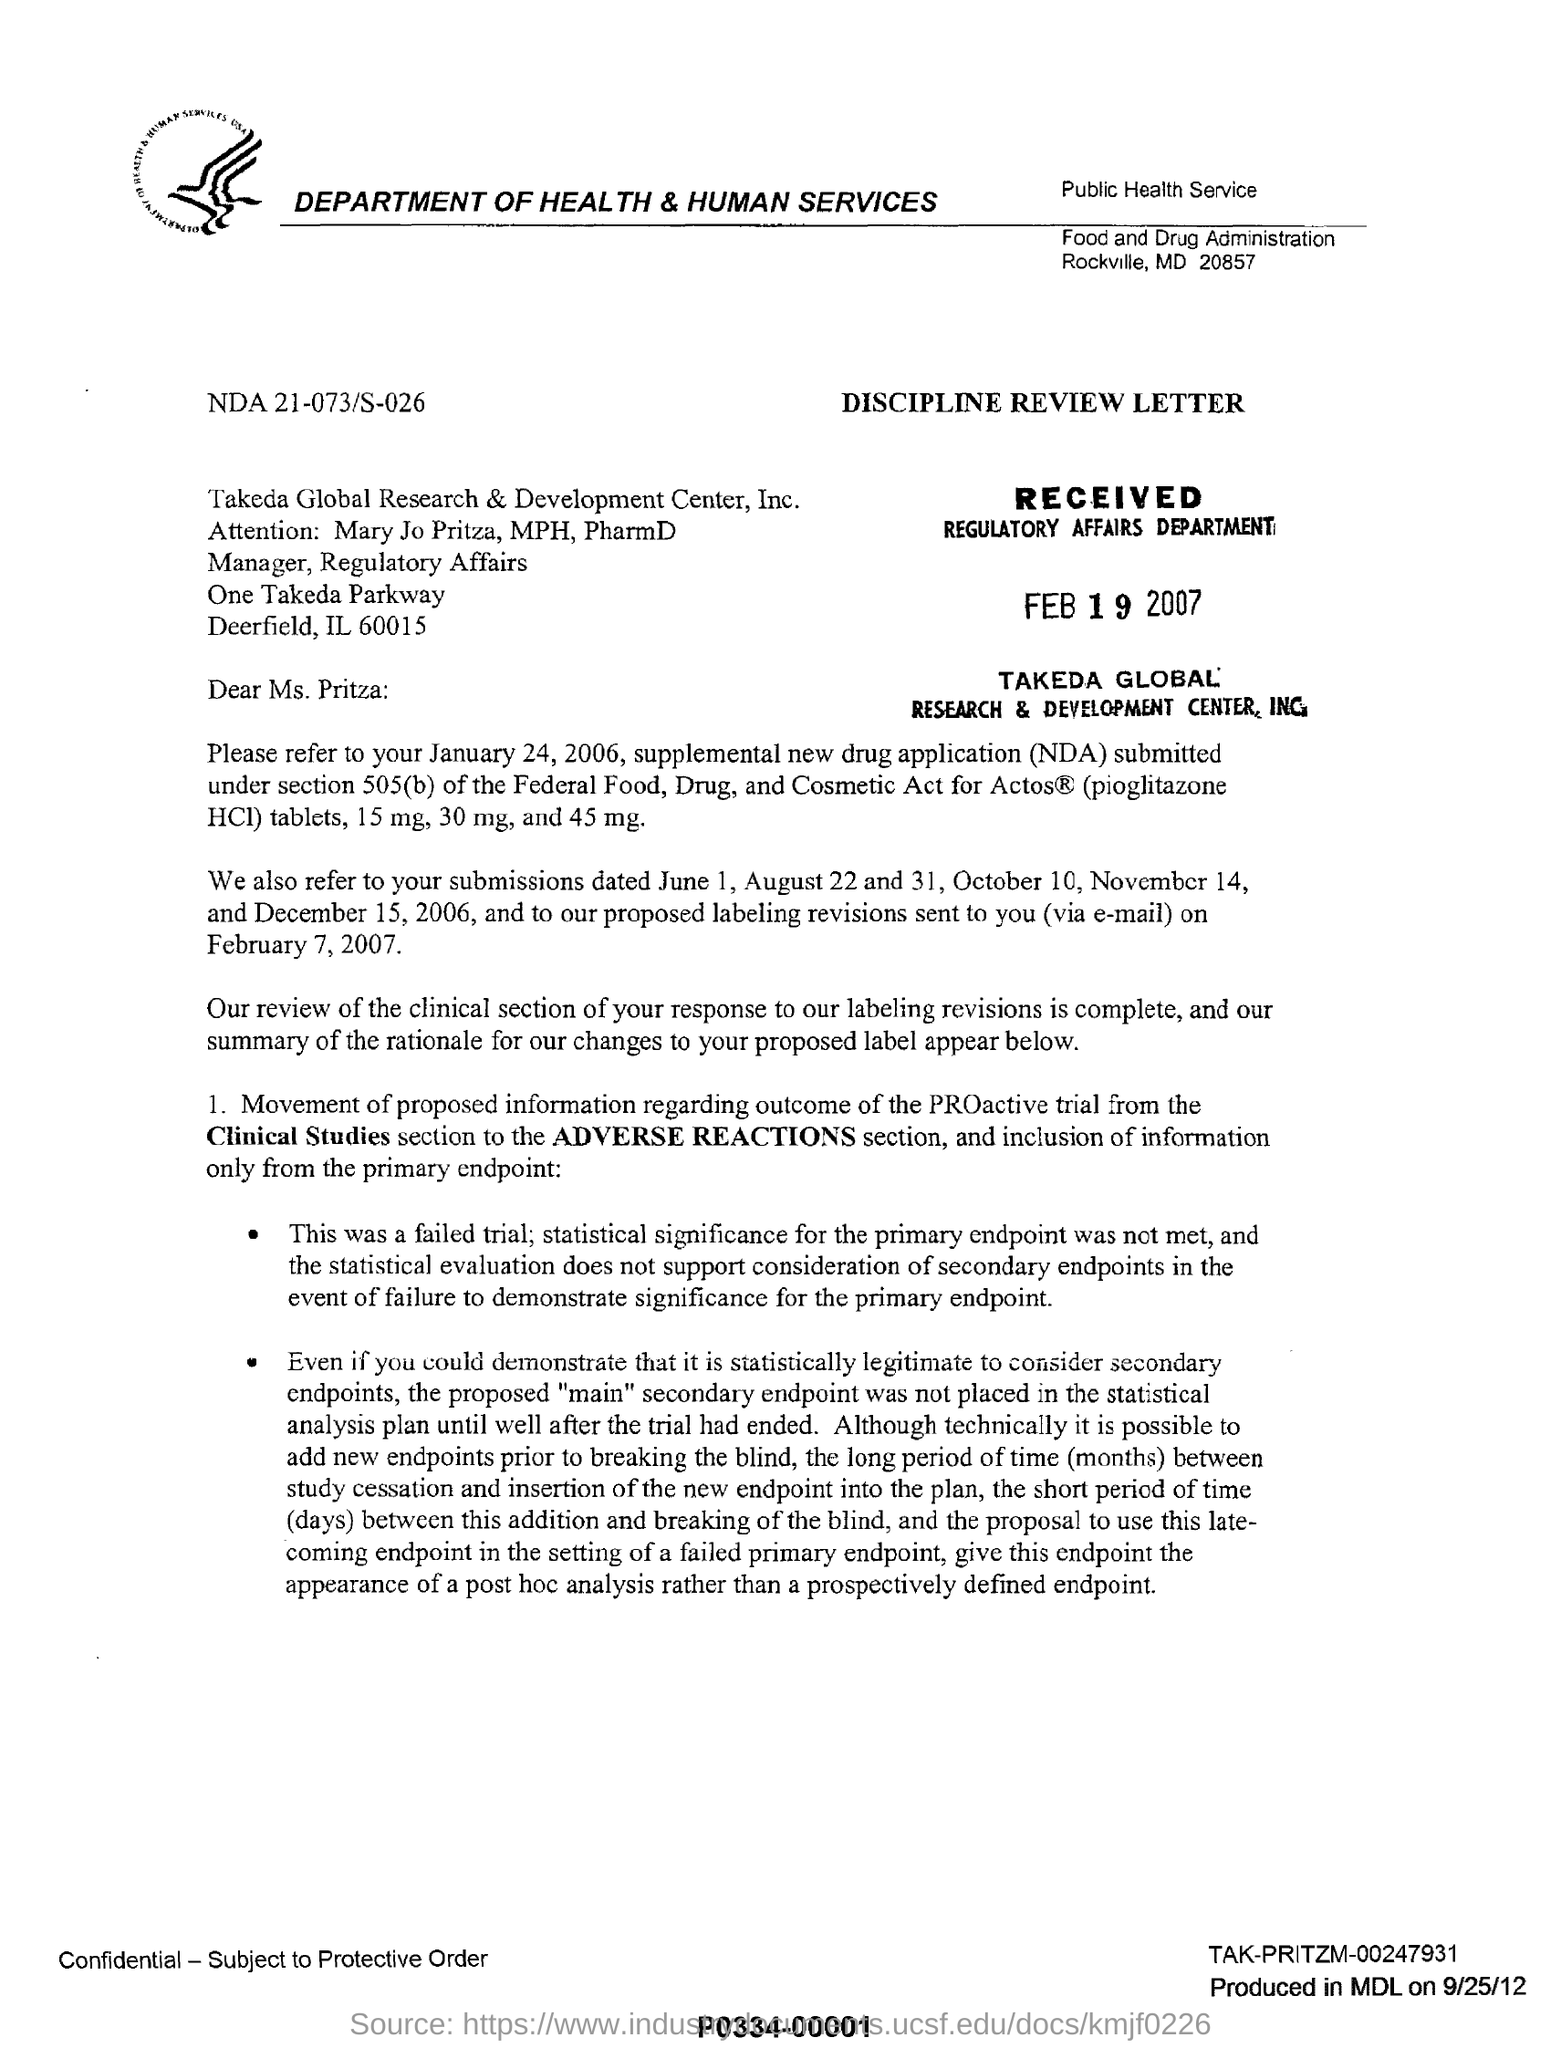Highlight a few significant elements in this photo. The full form of NDA is "New Drug Application," which is a process by which a pharmaceutical company seeks regulatory approval from the U.S. Food and Drug Administration (FDA) to market and sell a new drug in the United States. The Regulatory Affairs department received this letter on February 19, 2007. The addressee's name is Mary Jo Pritza, who holds a Master of Public Health degree and a Doctor of Pharmacy degree. The name of the company mentioned in the letterhead is: DEPARTMENT OF HEALTH & HUMAN SERVICES. This is a declaration sentence. 